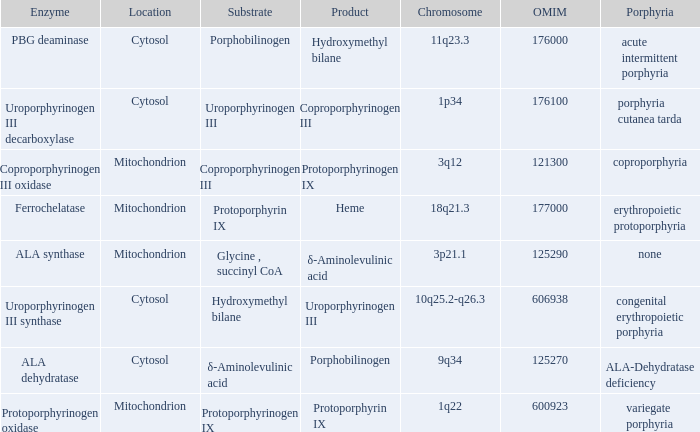What is the location of the enzyme Uroporphyrinogen iii Synthase? Cytosol. 